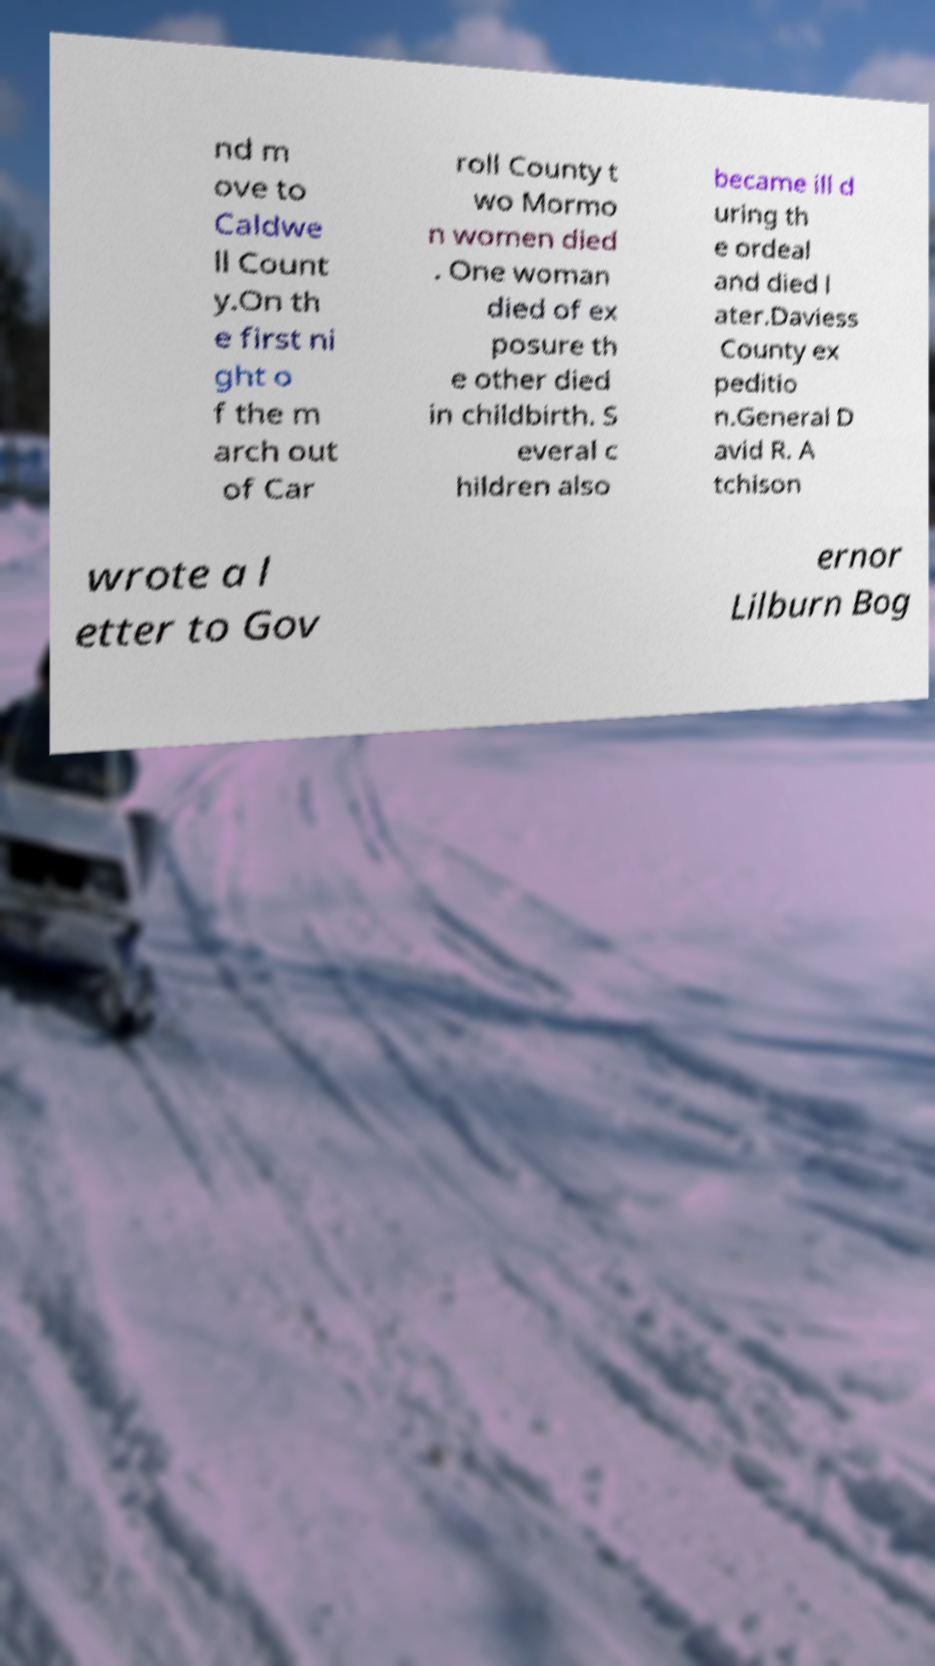I need the written content from this picture converted into text. Can you do that? nd m ove to Caldwe ll Count y.On th e first ni ght o f the m arch out of Car roll County t wo Mormo n women died . One woman died of ex posure th e other died in childbirth. S everal c hildren also became ill d uring th e ordeal and died l ater.Daviess County ex peditio n.General D avid R. A tchison wrote a l etter to Gov ernor Lilburn Bog 